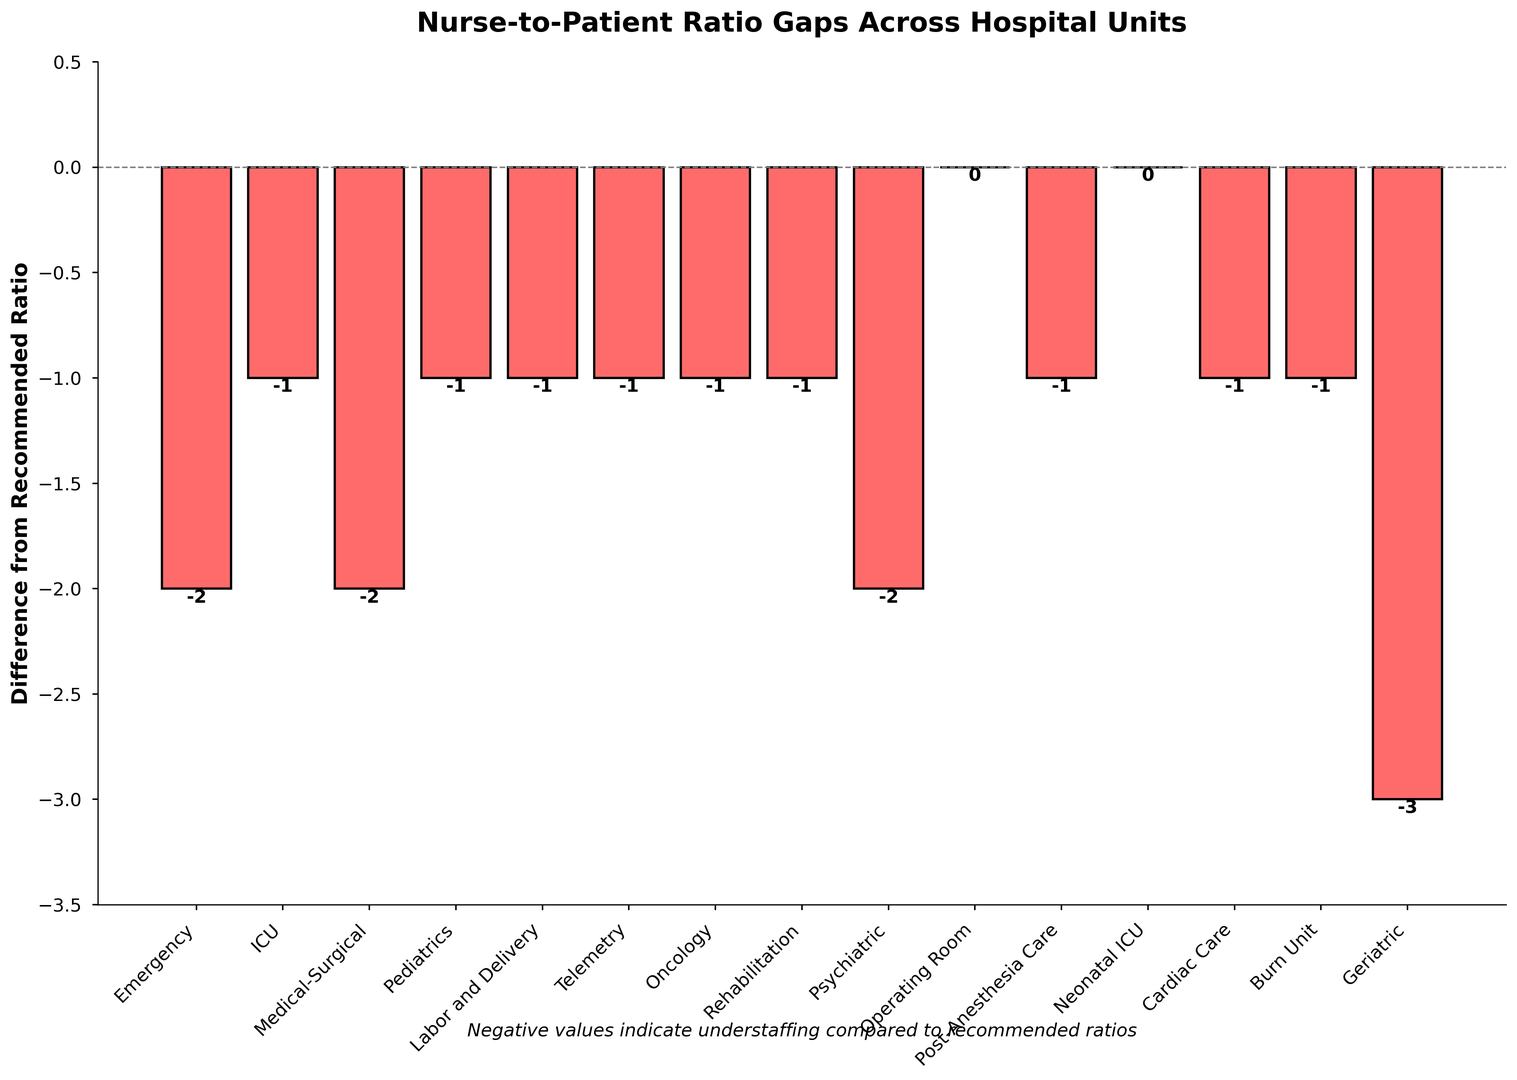Which hospital unit shows the highest nurse-to-patient ratio difference? The bar chart shows that the Geriatric unit has the longest bar in the negative direction, indicating the largest difference.
Answer: Geriatric How many units meet or exceed the recommended nurse-to-patient ratios? The bars at or above zero indicate units that meet or exceed the recommended ratios. From the chart, Operating Room and Neonatal ICU meet the standards.
Answer: 2 Which units have a nurse-to-patient ratio difference of -2? By observing the bars with the height of -2 on the chart, we identify the units: Emergency, Medical-Surgical, and Psychiatric.
Answer: Emergency, Medical-Surgical, Psychiatric What is the average difference from the recommended ratio for all units? Sum all differences and divide by the number of units (-2+-1+-2+-1+-1+-1+-1+-1+-2+0+-1+0+-1+-1+-3 = -18). There are 15 units, so the average is -18/15 = -1.2
Answer: -1.2 Which three units show the least negative difference in nurse-to-patient ratios? Inspecting the chart, the units with the least negative differences (closest to zero) are Operating Room and Neonatal ICU (both 0), followed by several units with -1 (ICU, Pediatrics, Labor and Delivery, Telemetry, Oncology, Rehabilitation, Post-Anesthesia Care, Cardiac Care, Burn Unit).
Answer: Operating Room, Neonatal ICU, and one of the units with -1 difference Are there more units with a nurse-to-patient difference of -1 or -2? Count the bars with a height of -1 and -2. There are 8 units with -1 and 3 units with -2. Hence, more units have a difference of -1.
Answer: -1 What is the sum of the nurse-to-patient ratio differences for the Medical-Surgical and Geriatric units? Identify the differences: Medical-Surgical (-2) and Geriatric (-3), then sum: -2 + (-3) = -5.
Answer: -5 Compare the nurse-to-patient ratio difference for the ICU unit to the difference for the Cardiac Care unit. Which unit has a better ratio? Check the chart: ICU has -1 and Cardiac Care also has -1.
Answer: Same (-1) Which unit has the smallest negative difference? The smallest negative difference is closer to zero. The chart shows Operating Room and Neonatal ICU have zero, followed by multiple units with -1.
Answer: Operating Room, Neonatal ICU If the Emergency, Medical-Surgical, and Psychiatric units were to meet their recommended ratios, what would be the total change in the difference? Each has a difference of -2. Thus, their cumulative change to reach zero difference is 3 units * 2 = 6.
Answer: 6 